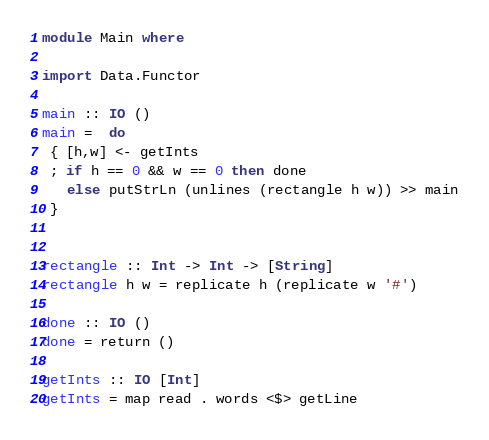<code> <loc_0><loc_0><loc_500><loc_500><_Haskell_>module Main where

import Data.Functor

main :: IO ()
main =  do
 { [h,w] <- getInts
 ; if h == 0 && w == 0 then done
   else putStrLn (unlines (rectangle h w)) >> main
 }


rectangle :: Int -> Int -> [String]
rectangle h w = replicate h (replicate w '#')

done :: IO ()
done = return ()

getInts :: IO [Int]
getInts = map read . words <$> getLine</code> 